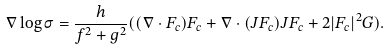<formula> <loc_0><loc_0><loc_500><loc_500>\nabla \log \sigma = \frac { h } { f ^ { 2 } + g ^ { 2 } } ( ( \nabla \cdot F _ { c } ) F _ { c } + \nabla \cdot ( J F _ { c } ) J F _ { c } + 2 | F _ { c } | ^ { 2 } G ) .</formula> 